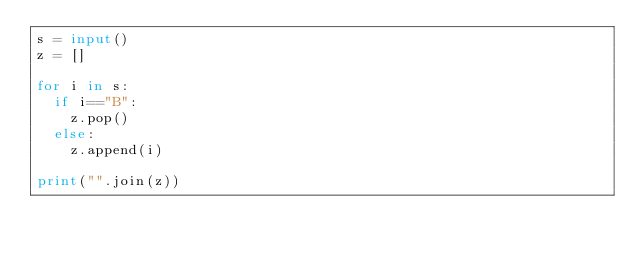Convert code to text. <code><loc_0><loc_0><loc_500><loc_500><_Python_>s = input()
z = []

for i in s:
  if i=="B":
    z.pop()
  else:
    z.append(i)

print("".join(z))</code> 